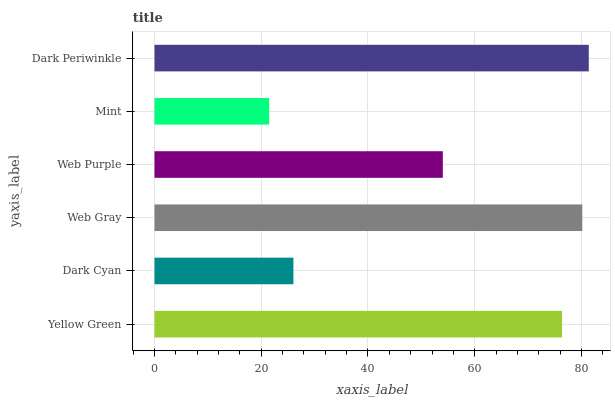Is Mint the minimum?
Answer yes or no. Yes. Is Dark Periwinkle the maximum?
Answer yes or no. Yes. Is Dark Cyan the minimum?
Answer yes or no. No. Is Dark Cyan the maximum?
Answer yes or no. No. Is Yellow Green greater than Dark Cyan?
Answer yes or no. Yes. Is Dark Cyan less than Yellow Green?
Answer yes or no. Yes. Is Dark Cyan greater than Yellow Green?
Answer yes or no. No. Is Yellow Green less than Dark Cyan?
Answer yes or no. No. Is Yellow Green the high median?
Answer yes or no. Yes. Is Web Purple the low median?
Answer yes or no. Yes. Is Dark Periwinkle the high median?
Answer yes or no. No. Is Dark Periwinkle the low median?
Answer yes or no. No. 